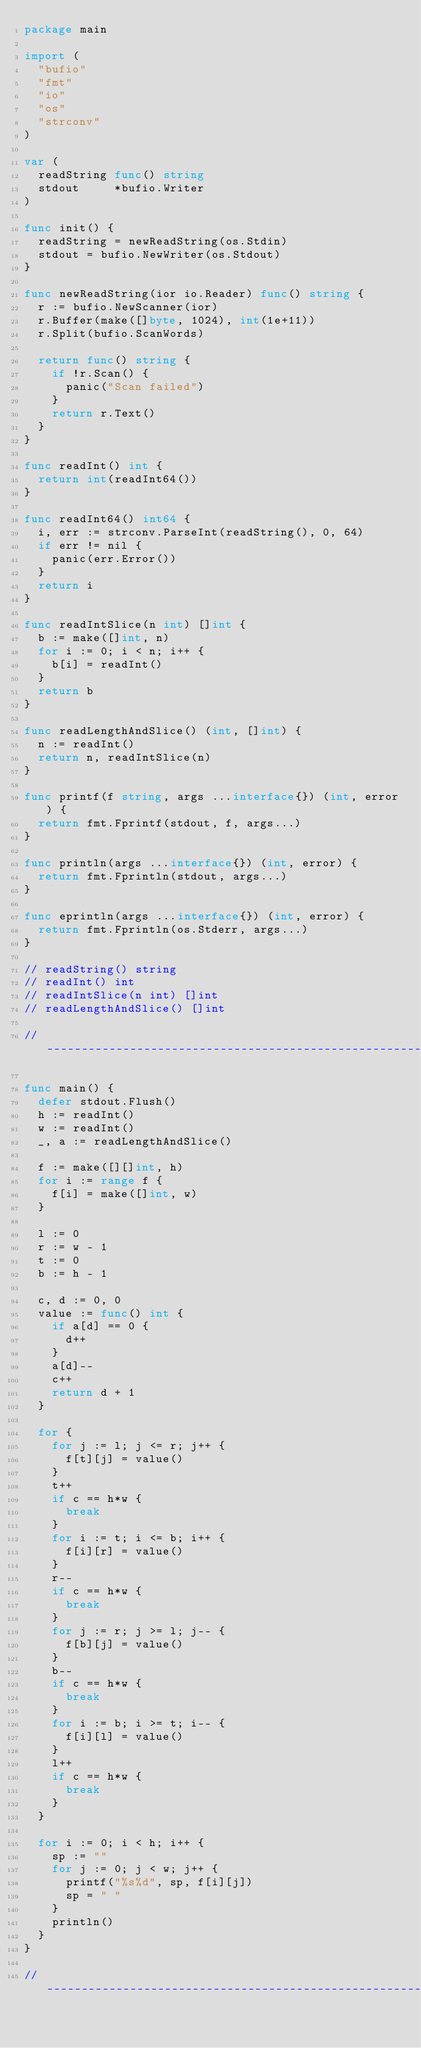Convert code to text. <code><loc_0><loc_0><loc_500><loc_500><_Go_>package main

import (
	"bufio"
	"fmt"
	"io"
	"os"
	"strconv"
)

var (
	readString func() string
	stdout     *bufio.Writer
)

func init() {
	readString = newReadString(os.Stdin)
	stdout = bufio.NewWriter(os.Stdout)
}

func newReadString(ior io.Reader) func() string {
	r := bufio.NewScanner(ior)
	r.Buffer(make([]byte, 1024), int(1e+11))
	r.Split(bufio.ScanWords)

	return func() string {
		if !r.Scan() {
			panic("Scan failed")
		}
		return r.Text()
	}
}

func readInt() int {
	return int(readInt64())
}

func readInt64() int64 {
	i, err := strconv.ParseInt(readString(), 0, 64)
	if err != nil {
		panic(err.Error())
	}
	return i
}

func readIntSlice(n int) []int {
	b := make([]int, n)
	for i := 0; i < n; i++ {
		b[i] = readInt()
	}
	return b
}

func readLengthAndSlice() (int, []int) {
	n := readInt()
	return n, readIntSlice(n)
}

func printf(f string, args ...interface{}) (int, error) {
	return fmt.Fprintf(stdout, f, args...)
}

func println(args ...interface{}) (int, error) {
	return fmt.Fprintln(stdout, args...)
}

func eprintln(args ...interface{}) (int, error) {
	return fmt.Fprintln(os.Stderr, args...)
}

// readString() string
// readInt() int
// readIntSlice(n int) []int
// readLengthAndSlice() []int

// -----------------------------------------------------------------------------

func main() {
	defer stdout.Flush()
	h := readInt()
	w := readInt()
	_, a := readLengthAndSlice()

	f := make([][]int, h)
	for i := range f {
		f[i] = make([]int, w)
	}

	l := 0
	r := w - 1
	t := 0
	b := h - 1

	c, d := 0, 0
	value := func() int {
		if a[d] == 0 {
			d++
		}
		a[d]--
		c++
		return d + 1
	}

	for {
		for j := l; j <= r; j++ {
			f[t][j] = value()
		}
		t++
		if c == h*w {
			break
		}
		for i := t; i <= b; i++ {
			f[i][r] = value()
		}
		r--
		if c == h*w {
			break
		}
		for j := r; j >= l; j-- {
			f[b][j] = value()
		}
		b--
		if c == h*w {
			break
		}
		for i := b; i >= t; i-- {
			f[i][l] = value()
		}
		l++
		if c == h*w {
			break
		}
	}

	for i := 0; i < h; i++ {
		sp := ""
		for j := 0; j < w; j++ {
			printf("%s%d", sp, f[i][j])
			sp = " "
		}
		println()
	}
}

// -----------------------------------------------------------------------------
</code> 